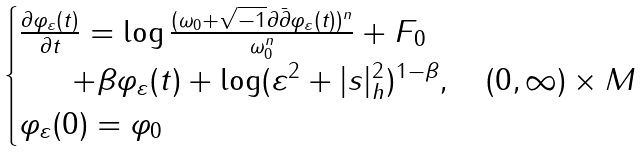<formula> <loc_0><loc_0><loc_500><loc_500>\begin{cases} \frac { \partial \varphi _ { \varepsilon } ( t ) } { \partial t } = \log \frac { ( \omega _ { 0 } + \sqrt { - 1 } \partial \bar { \partial } \varphi _ { \varepsilon } ( t ) ) ^ { n } } { \omega _ { 0 } ^ { n } } + F _ { 0 } \\ \quad \ \ + \beta \varphi _ { \varepsilon } ( t ) + \log ( \varepsilon ^ { 2 } + | s | _ { h } ^ { 2 } ) ^ { 1 - \beta } , \quad ( 0 , \infty ) \times M \\ \varphi _ { \varepsilon } ( 0 ) = \varphi _ { 0 } \\ \end{cases}</formula> 